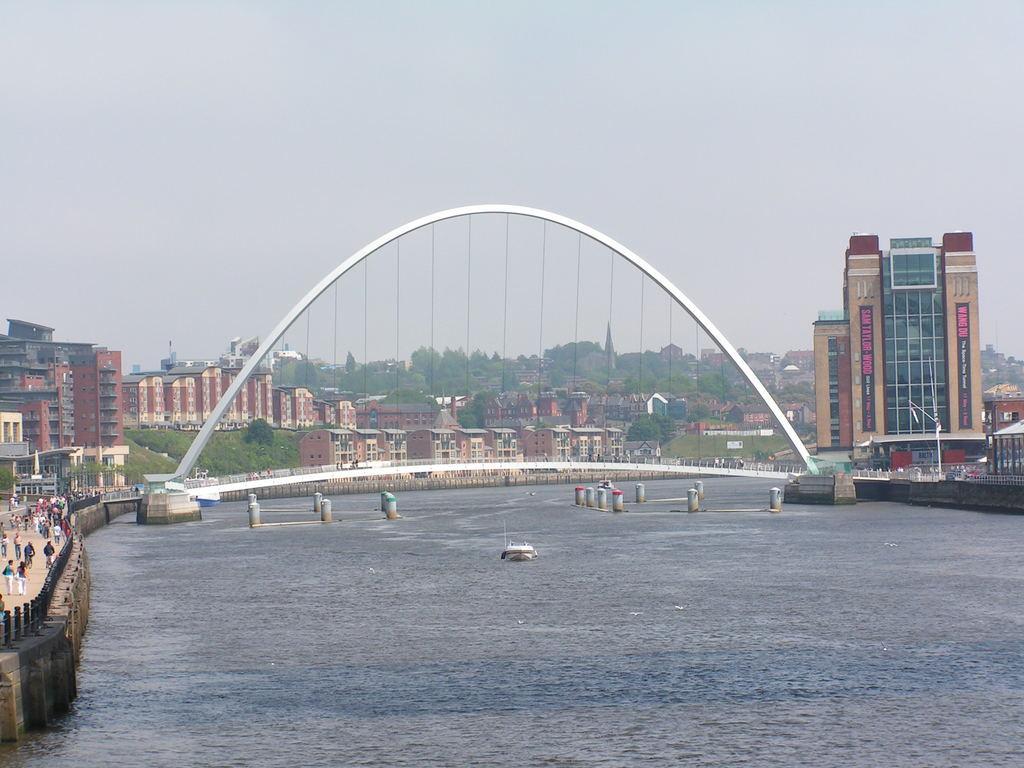How would you summarize this image in a sentence or two? In this image we can see buildings, trees, bridge, boat, water and we can also see the sky. 